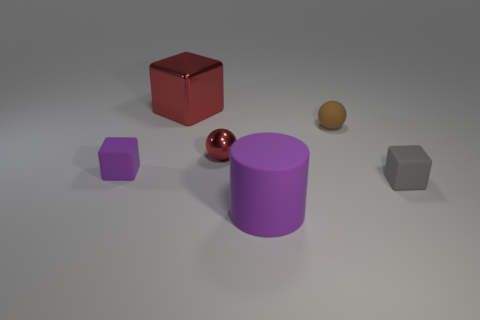Subtract all shiny cubes. How many cubes are left? 2 Add 4 matte spheres. How many objects exist? 10 Subtract all cylinders. How many objects are left? 5 Subtract all large brown rubber spheres. Subtract all brown matte spheres. How many objects are left? 5 Add 5 brown spheres. How many brown spheres are left? 6 Add 6 large red metallic blocks. How many large red metallic blocks exist? 7 Subtract 0 yellow blocks. How many objects are left? 6 Subtract all red blocks. Subtract all green cylinders. How many blocks are left? 2 